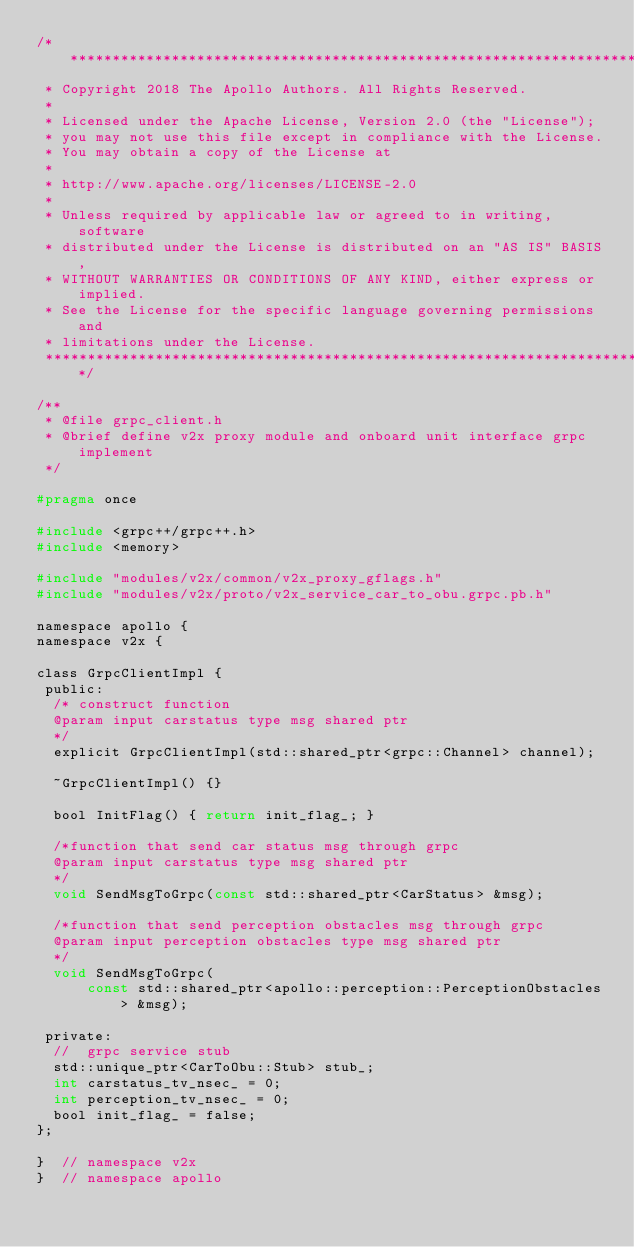<code> <loc_0><loc_0><loc_500><loc_500><_C_>/******************************************************************************
 * Copyright 2018 The Apollo Authors. All Rights Reserved.
 *
 * Licensed under the Apache License, Version 2.0 (the "License");
 * you may not use this file except in compliance with the License.
 * You may obtain a copy of the License at
 *
 * http://www.apache.org/licenses/LICENSE-2.0
 *
 * Unless required by applicable law or agreed to in writing, software
 * distributed under the License is distributed on an "AS IS" BASIS,
 * WITHOUT WARRANTIES OR CONDITIONS OF ANY KIND, either express or implied.
 * See the License for the specific language governing permissions and
 * limitations under the License.
 *****************************************************************************/

/**
 * @file grpc_client.h
 * @brief define v2x proxy module and onboard unit interface grpc implement
 */

#pragma once

#include <grpc++/grpc++.h>
#include <memory>

#include "modules/v2x/common/v2x_proxy_gflags.h"
#include "modules/v2x/proto/v2x_service_car_to_obu.grpc.pb.h"

namespace apollo {
namespace v2x {

class GrpcClientImpl {
 public:
  /* construct function
  @param input carstatus type msg shared ptr
  */
  explicit GrpcClientImpl(std::shared_ptr<grpc::Channel> channel);

  ~GrpcClientImpl() {}

  bool InitFlag() { return init_flag_; }

  /*function that send car status msg through grpc
  @param input carstatus type msg shared ptr
  */
  void SendMsgToGrpc(const std::shared_ptr<CarStatus> &msg);

  /*function that send perception obstacles msg through grpc
  @param input perception obstacles type msg shared ptr
  */
  void SendMsgToGrpc(
      const std::shared_ptr<apollo::perception::PerceptionObstacles> &msg);

 private:
  //  grpc service stub
  std::unique_ptr<CarToObu::Stub> stub_;
  int carstatus_tv_nsec_ = 0;
  int perception_tv_nsec_ = 0;
  bool init_flag_ = false;
};

}  // namespace v2x
}  // namespace apollo
</code> 